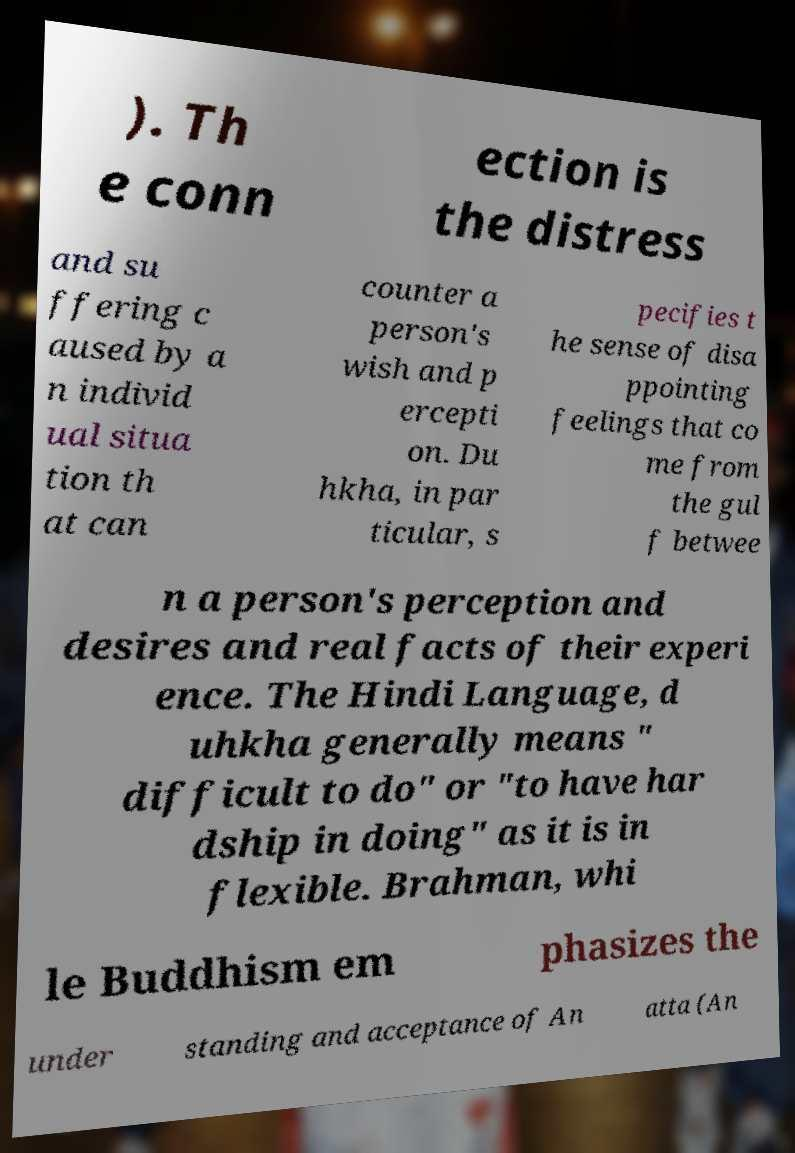Please read and relay the text visible in this image. What does it say? ). Th e conn ection is the distress and su ffering c aused by a n individ ual situa tion th at can counter a person's wish and p ercepti on. Du hkha, in par ticular, s pecifies t he sense of disa ppointing feelings that co me from the gul f betwee n a person's perception and desires and real facts of their experi ence. The Hindi Language, d uhkha generally means " difficult to do" or "to have har dship in doing" as it is in flexible. Brahman, whi le Buddhism em phasizes the under standing and acceptance of An atta (An 